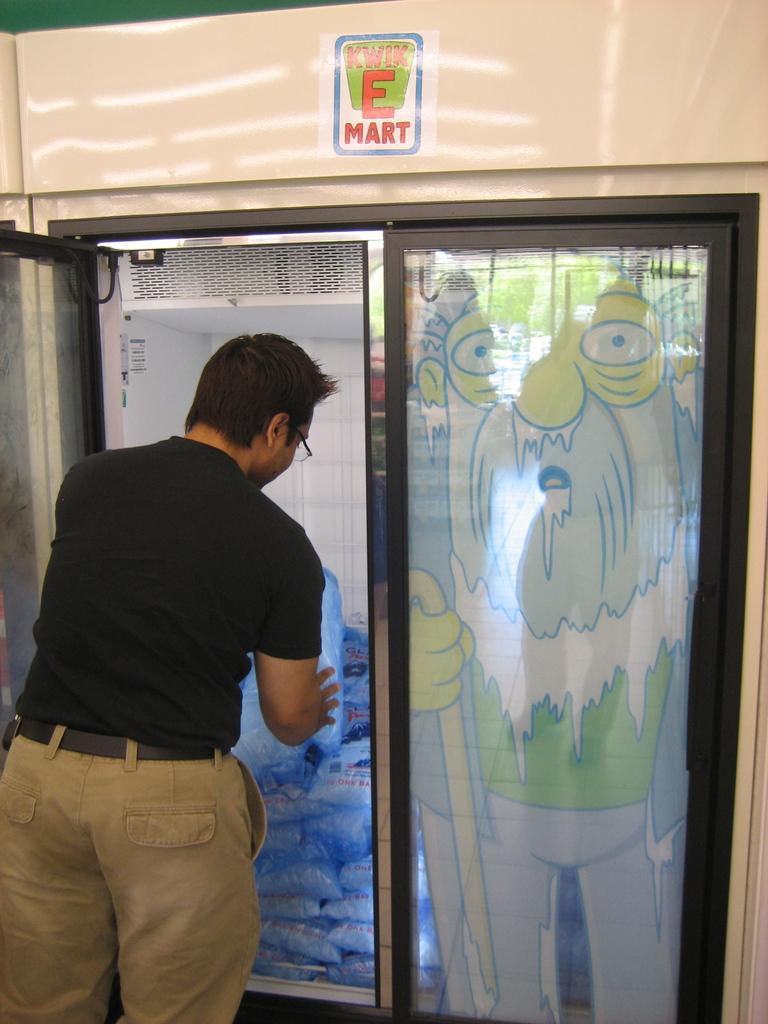<image>
Relay a brief, clear account of the picture shown. A man removes a bag of ice from a Kwik E Mart store freezer. 